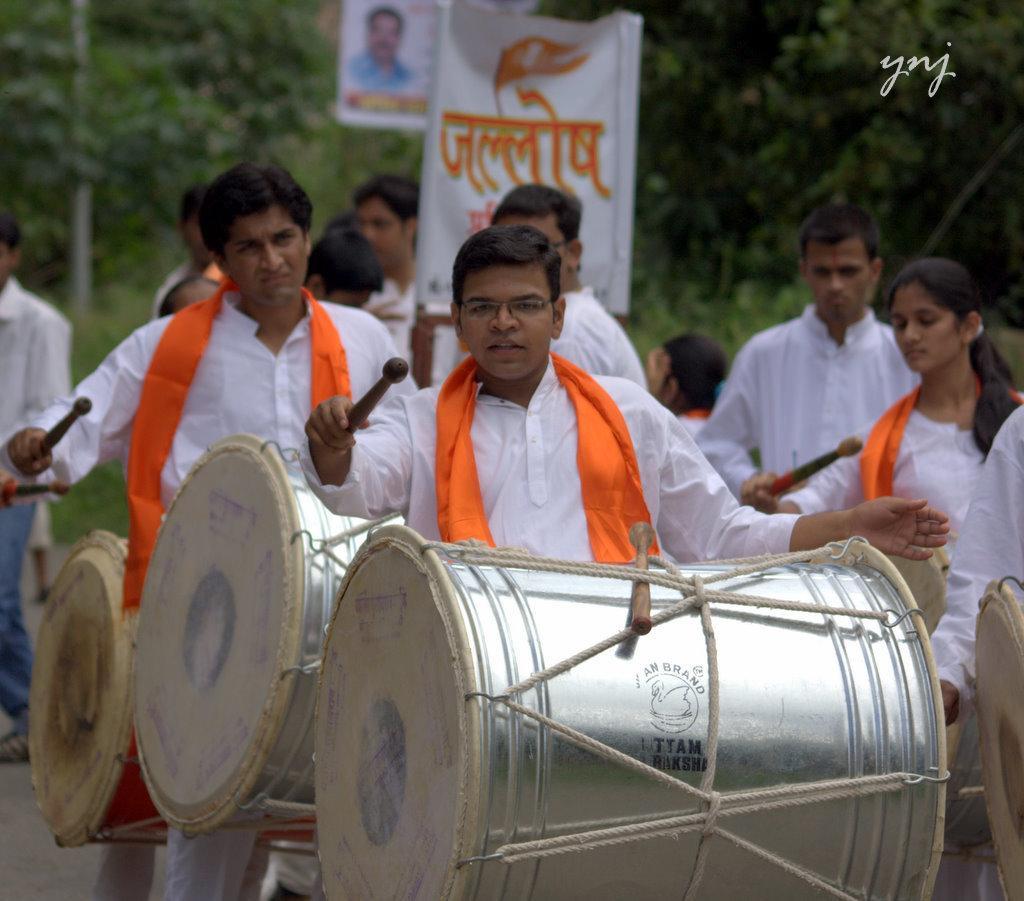Could you give a brief overview of what you see in this image? in the picture we can see the persons holding the drums and playing it with a stick her we can see a banner and we can also see trees behind them. 